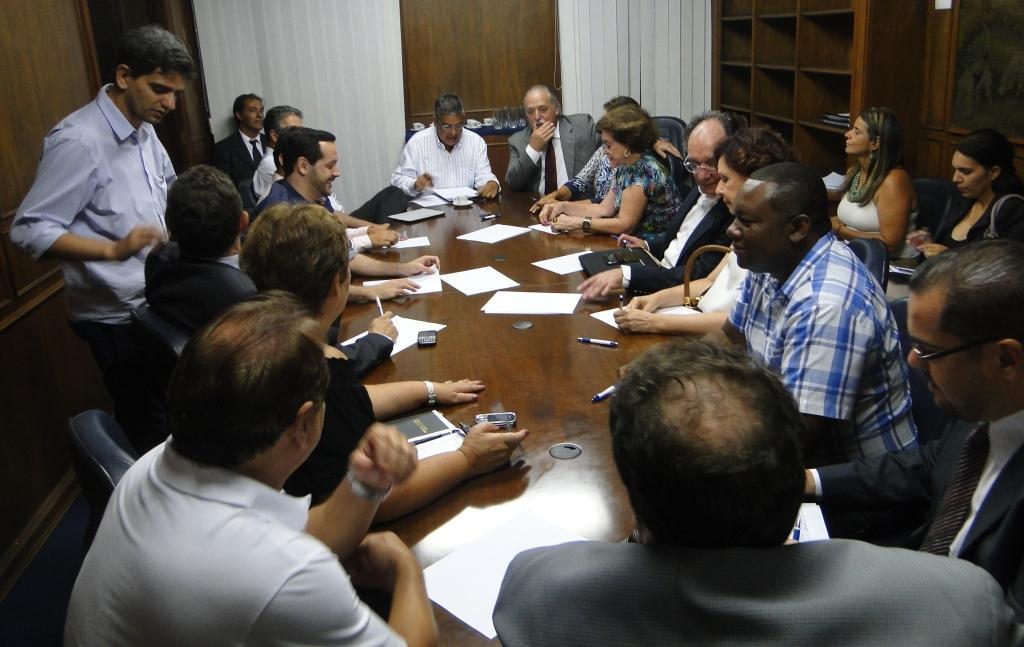Could you give a brief overview of what you see in this image? In this picture we can see there are a group of people are sitting on chairs and a man is standing on the path. Behind the people there are rocks and wooden wall. 